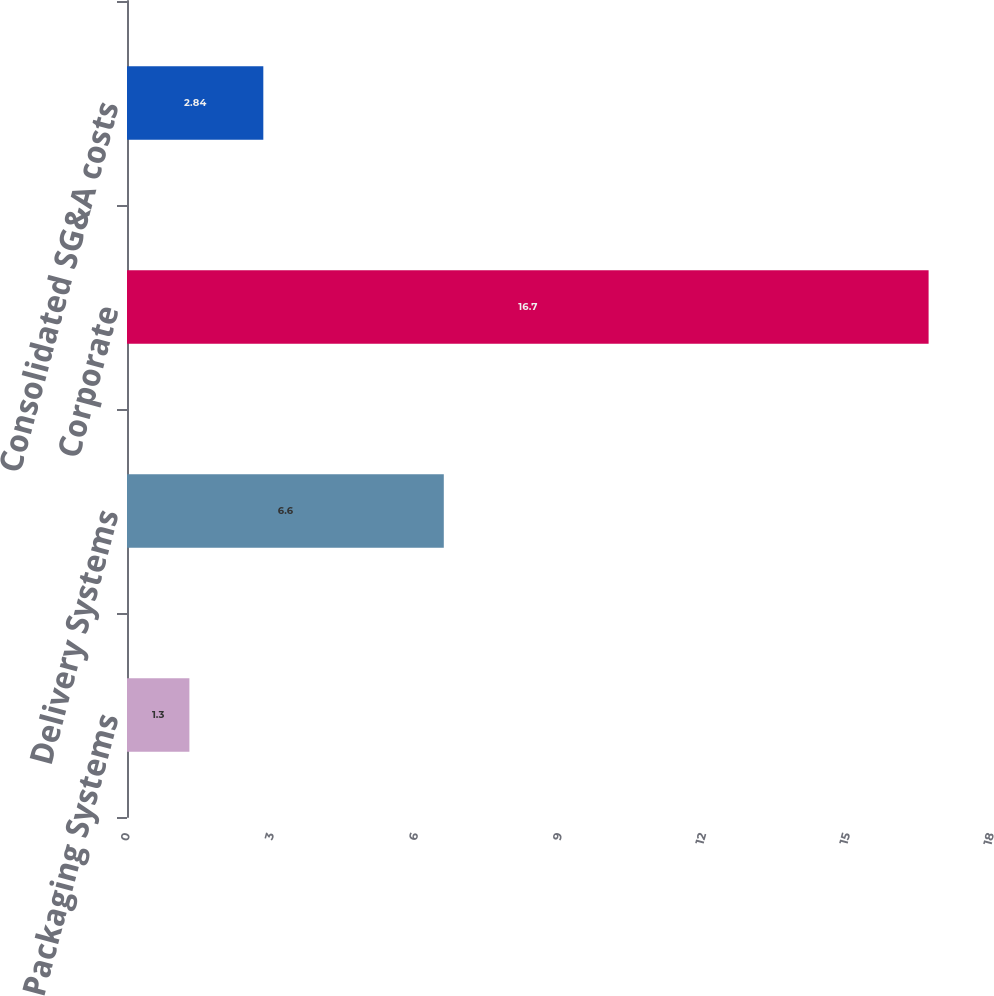Convert chart. <chart><loc_0><loc_0><loc_500><loc_500><bar_chart><fcel>Packaging Systems<fcel>Delivery Systems<fcel>Corporate<fcel>Consolidated SG&A costs<nl><fcel>1.3<fcel>6.6<fcel>16.7<fcel>2.84<nl></chart> 